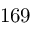Convert formula to latex. <formula><loc_0><loc_0><loc_500><loc_500>1 6 9</formula> 